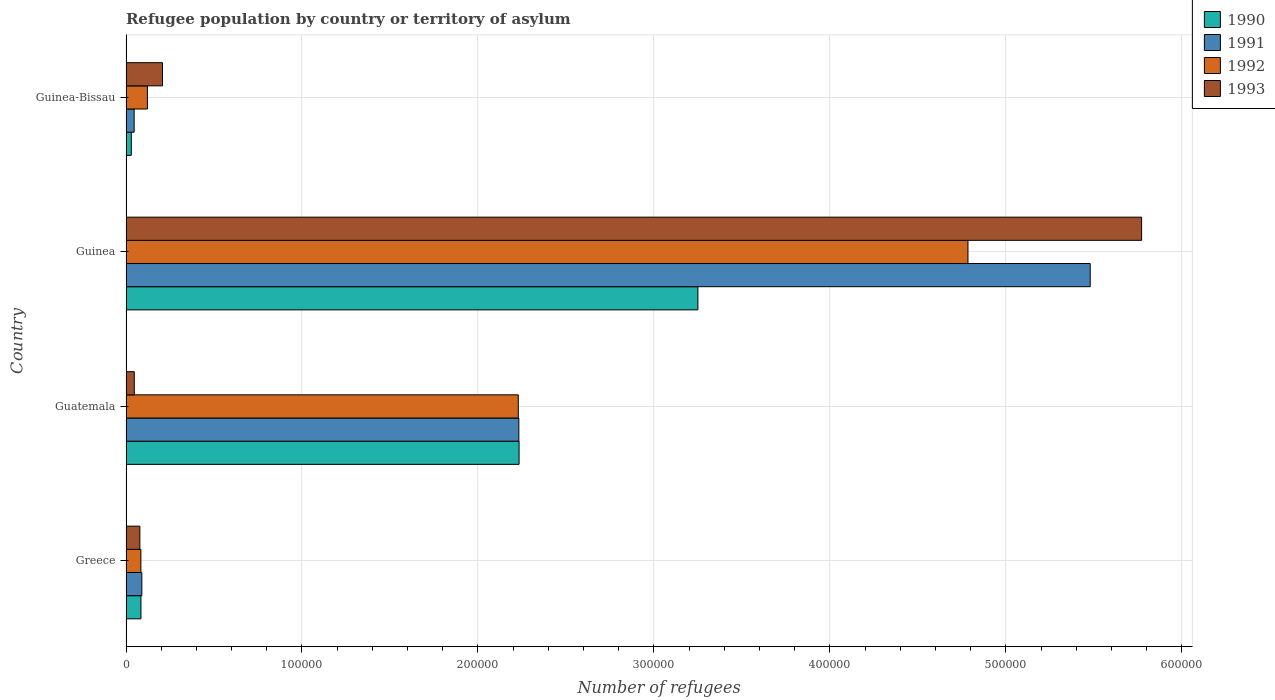How many different coloured bars are there?
Your answer should be compact. 4. How many bars are there on the 3rd tick from the top?
Make the answer very short. 4. How many bars are there on the 2nd tick from the bottom?
Offer a terse response. 4. What is the number of refugees in 1993 in Guinea-Bissau?
Your answer should be compact. 2.07e+04. Across all countries, what is the maximum number of refugees in 1993?
Your answer should be very brief. 5.77e+05. Across all countries, what is the minimum number of refugees in 1992?
Provide a short and direct response. 8456. In which country was the number of refugees in 1992 maximum?
Offer a terse response. Guinea. In which country was the number of refugees in 1990 minimum?
Offer a very short reply. Guinea-Bissau. What is the total number of refugees in 1993 in the graph?
Give a very brief answer. 6.10e+05. What is the difference between the number of refugees in 1993 in Guatemala and that in Guinea-Bissau?
Provide a succinct answer. -1.60e+04. What is the difference between the number of refugees in 1990 in Guinea and the number of refugees in 1993 in Greece?
Give a very brief answer. 3.17e+05. What is the average number of refugees in 1992 per country?
Make the answer very short. 1.81e+05. What is the difference between the number of refugees in 1993 and number of refugees in 1991 in Guinea-Bissau?
Offer a terse response. 1.61e+04. In how many countries, is the number of refugees in 1993 greater than 300000 ?
Offer a very short reply. 1. What is the ratio of the number of refugees in 1993 in Guatemala to that in Guinea-Bissau?
Your response must be concise. 0.23. Is the difference between the number of refugees in 1993 in Greece and Guinea greater than the difference between the number of refugees in 1991 in Greece and Guinea?
Offer a terse response. No. What is the difference between the highest and the second highest number of refugees in 1991?
Give a very brief answer. 3.25e+05. What is the difference between the highest and the lowest number of refugees in 1992?
Make the answer very short. 4.70e+05. Is the sum of the number of refugees in 1990 in Greece and Guinea greater than the maximum number of refugees in 1992 across all countries?
Provide a succinct answer. No. What does the 4th bar from the top in Guinea-Bissau represents?
Make the answer very short. 1990. What does the 2nd bar from the bottom in Greece represents?
Ensure brevity in your answer.  1991. Is it the case that in every country, the sum of the number of refugees in 1991 and number of refugees in 1993 is greater than the number of refugees in 1992?
Ensure brevity in your answer.  Yes. How many bars are there?
Offer a very short reply. 16. Are all the bars in the graph horizontal?
Offer a terse response. Yes. How many countries are there in the graph?
Your response must be concise. 4. What is the difference between two consecutive major ticks on the X-axis?
Your response must be concise. 1.00e+05. Does the graph contain any zero values?
Keep it short and to the point. No. Does the graph contain grids?
Your answer should be very brief. Yes. Where does the legend appear in the graph?
Your response must be concise. Top right. How many legend labels are there?
Make the answer very short. 4. What is the title of the graph?
Provide a short and direct response. Refugee population by country or territory of asylum. Does "1975" appear as one of the legend labels in the graph?
Give a very brief answer. No. What is the label or title of the X-axis?
Offer a terse response. Number of refugees. What is the Number of refugees in 1990 in Greece?
Your answer should be compact. 8488. What is the Number of refugees in 1991 in Greece?
Offer a terse response. 8989. What is the Number of refugees of 1992 in Greece?
Offer a very short reply. 8456. What is the Number of refugees of 1993 in Greece?
Provide a succinct answer. 7873. What is the Number of refugees of 1990 in Guatemala?
Offer a terse response. 2.23e+05. What is the Number of refugees of 1991 in Guatemala?
Make the answer very short. 2.23e+05. What is the Number of refugees of 1992 in Guatemala?
Offer a terse response. 2.23e+05. What is the Number of refugees of 1993 in Guatemala?
Your answer should be very brief. 4689. What is the Number of refugees of 1990 in Guinea?
Your answer should be very brief. 3.25e+05. What is the Number of refugees of 1991 in Guinea?
Keep it short and to the point. 5.48e+05. What is the Number of refugees of 1992 in Guinea?
Keep it short and to the point. 4.78e+05. What is the Number of refugees in 1993 in Guinea?
Give a very brief answer. 5.77e+05. What is the Number of refugees of 1990 in Guinea-Bissau?
Offer a terse response. 3004. What is the Number of refugees of 1991 in Guinea-Bissau?
Ensure brevity in your answer.  4631. What is the Number of refugees in 1992 in Guinea-Bissau?
Keep it short and to the point. 1.22e+04. What is the Number of refugees in 1993 in Guinea-Bissau?
Keep it short and to the point. 2.07e+04. Across all countries, what is the maximum Number of refugees of 1990?
Provide a succinct answer. 3.25e+05. Across all countries, what is the maximum Number of refugees in 1991?
Provide a short and direct response. 5.48e+05. Across all countries, what is the maximum Number of refugees of 1992?
Your answer should be very brief. 4.78e+05. Across all countries, what is the maximum Number of refugees of 1993?
Offer a very short reply. 5.77e+05. Across all countries, what is the minimum Number of refugees in 1990?
Your answer should be very brief. 3004. Across all countries, what is the minimum Number of refugees of 1991?
Offer a very short reply. 4631. Across all countries, what is the minimum Number of refugees in 1992?
Your response must be concise. 8456. Across all countries, what is the minimum Number of refugees of 1993?
Offer a very short reply. 4689. What is the total Number of refugees of 1990 in the graph?
Make the answer very short. 5.60e+05. What is the total Number of refugees of 1991 in the graph?
Your answer should be very brief. 7.85e+05. What is the total Number of refugees of 1992 in the graph?
Provide a succinct answer. 7.22e+05. What is the total Number of refugees in 1993 in the graph?
Give a very brief answer. 6.10e+05. What is the difference between the Number of refugees in 1990 in Greece and that in Guatemala?
Give a very brief answer. -2.15e+05. What is the difference between the Number of refugees of 1991 in Greece and that in Guatemala?
Keep it short and to the point. -2.14e+05. What is the difference between the Number of refugees in 1992 in Greece and that in Guatemala?
Keep it short and to the point. -2.14e+05. What is the difference between the Number of refugees in 1993 in Greece and that in Guatemala?
Make the answer very short. 3184. What is the difference between the Number of refugees in 1990 in Greece and that in Guinea?
Make the answer very short. -3.17e+05. What is the difference between the Number of refugees of 1991 in Greece and that in Guinea?
Offer a very short reply. -5.39e+05. What is the difference between the Number of refugees in 1992 in Greece and that in Guinea?
Ensure brevity in your answer.  -4.70e+05. What is the difference between the Number of refugees of 1993 in Greece and that in Guinea?
Provide a short and direct response. -5.69e+05. What is the difference between the Number of refugees in 1990 in Greece and that in Guinea-Bissau?
Offer a terse response. 5484. What is the difference between the Number of refugees of 1991 in Greece and that in Guinea-Bissau?
Offer a terse response. 4358. What is the difference between the Number of refugees in 1992 in Greece and that in Guinea-Bissau?
Provide a succinct answer. -3707. What is the difference between the Number of refugees of 1993 in Greece and that in Guinea-Bissau?
Ensure brevity in your answer.  -1.29e+04. What is the difference between the Number of refugees in 1990 in Guatemala and that in Guinea?
Offer a very short reply. -1.02e+05. What is the difference between the Number of refugees in 1991 in Guatemala and that in Guinea?
Provide a succinct answer. -3.25e+05. What is the difference between the Number of refugees in 1992 in Guatemala and that in Guinea?
Offer a terse response. -2.56e+05. What is the difference between the Number of refugees of 1993 in Guatemala and that in Guinea?
Your answer should be compact. -5.72e+05. What is the difference between the Number of refugees of 1990 in Guatemala and that in Guinea-Bissau?
Provide a short and direct response. 2.20e+05. What is the difference between the Number of refugees of 1991 in Guatemala and that in Guinea-Bissau?
Make the answer very short. 2.19e+05. What is the difference between the Number of refugees in 1992 in Guatemala and that in Guinea-Bissau?
Give a very brief answer. 2.11e+05. What is the difference between the Number of refugees in 1993 in Guatemala and that in Guinea-Bissau?
Offer a very short reply. -1.60e+04. What is the difference between the Number of refugees of 1990 in Guinea and that in Guinea-Bissau?
Your response must be concise. 3.22e+05. What is the difference between the Number of refugees in 1991 in Guinea and that in Guinea-Bissau?
Offer a terse response. 5.43e+05. What is the difference between the Number of refugees of 1992 in Guinea and that in Guinea-Bissau?
Provide a succinct answer. 4.66e+05. What is the difference between the Number of refugees in 1993 in Guinea and that in Guinea-Bissau?
Your answer should be compact. 5.56e+05. What is the difference between the Number of refugees in 1990 in Greece and the Number of refugees in 1991 in Guatemala?
Your answer should be compact. -2.15e+05. What is the difference between the Number of refugees in 1990 in Greece and the Number of refugees in 1992 in Guatemala?
Make the answer very short. -2.14e+05. What is the difference between the Number of refugees in 1990 in Greece and the Number of refugees in 1993 in Guatemala?
Provide a succinct answer. 3799. What is the difference between the Number of refugees of 1991 in Greece and the Number of refugees of 1992 in Guatemala?
Your answer should be very brief. -2.14e+05. What is the difference between the Number of refugees in 1991 in Greece and the Number of refugees in 1993 in Guatemala?
Keep it short and to the point. 4300. What is the difference between the Number of refugees in 1992 in Greece and the Number of refugees in 1993 in Guatemala?
Make the answer very short. 3767. What is the difference between the Number of refugees in 1990 in Greece and the Number of refugees in 1991 in Guinea?
Provide a succinct answer. -5.39e+05. What is the difference between the Number of refugees of 1990 in Greece and the Number of refugees of 1992 in Guinea?
Keep it short and to the point. -4.70e+05. What is the difference between the Number of refugees in 1990 in Greece and the Number of refugees in 1993 in Guinea?
Give a very brief answer. -5.69e+05. What is the difference between the Number of refugees of 1991 in Greece and the Number of refugees of 1992 in Guinea?
Your response must be concise. -4.70e+05. What is the difference between the Number of refugees of 1991 in Greece and the Number of refugees of 1993 in Guinea?
Keep it short and to the point. -5.68e+05. What is the difference between the Number of refugees of 1992 in Greece and the Number of refugees of 1993 in Guinea?
Give a very brief answer. -5.69e+05. What is the difference between the Number of refugees of 1990 in Greece and the Number of refugees of 1991 in Guinea-Bissau?
Provide a short and direct response. 3857. What is the difference between the Number of refugees of 1990 in Greece and the Number of refugees of 1992 in Guinea-Bissau?
Make the answer very short. -3675. What is the difference between the Number of refugees in 1990 in Greece and the Number of refugees in 1993 in Guinea-Bissau?
Your response must be concise. -1.22e+04. What is the difference between the Number of refugees in 1991 in Greece and the Number of refugees in 1992 in Guinea-Bissau?
Provide a short and direct response. -3174. What is the difference between the Number of refugees of 1991 in Greece and the Number of refugees of 1993 in Guinea-Bissau?
Give a very brief answer. -1.17e+04. What is the difference between the Number of refugees of 1992 in Greece and the Number of refugees of 1993 in Guinea-Bissau?
Your answer should be compact. -1.23e+04. What is the difference between the Number of refugees of 1990 in Guatemala and the Number of refugees of 1991 in Guinea?
Ensure brevity in your answer.  -3.25e+05. What is the difference between the Number of refugees of 1990 in Guatemala and the Number of refugees of 1992 in Guinea?
Offer a very short reply. -2.55e+05. What is the difference between the Number of refugees of 1990 in Guatemala and the Number of refugees of 1993 in Guinea?
Offer a terse response. -3.54e+05. What is the difference between the Number of refugees in 1991 in Guatemala and the Number of refugees in 1992 in Guinea?
Your answer should be very brief. -2.55e+05. What is the difference between the Number of refugees of 1991 in Guatemala and the Number of refugees of 1993 in Guinea?
Offer a terse response. -3.54e+05. What is the difference between the Number of refugees of 1992 in Guatemala and the Number of refugees of 1993 in Guinea?
Your answer should be compact. -3.54e+05. What is the difference between the Number of refugees in 1990 in Guatemala and the Number of refugees in 1991 in Guinea-Bissau?
Your answer should be very brief. 2.19e+05. What is the difference between the Number of refugees of 1990 in Guatemala and the Number of refugees of 1992 in Guinea-Bissau?
Your response must be concise. 2.11e+05. What is the difference between the Number of refugees in 1990 in Guatemala and the Number of refugees in 1993 in Guinea-Bissau?
Your response must be concise. 2.03e+05. What is the difference between the Number of refugees in 1991 in Guatemala and the Number of refugees in 1992 in Guinea-Bissau?
Your answer should be compact. 2.11e+05. What is the difference between the Number of refugees of 1991 in Guatemala and the Number of refugees of 1993 in Guinea-Bissau?
Your answer should be very brief. 2.03e+05. What is the difference between the Number of refugees in 1992 in Guatemala and the Number of refugees in 1993 in Guinea-Bissau?
Keep it short and to the point. 2.02e+05. What is the difference between the Number of refugees of 1990 in Guinea and the Number of refugees of 1991 in Guinea-Bissau?
Your answer should be compact. 3.20e+05. What is the difference between the Number of refugees in 1990 in Guinea and the Number of refugees in 1992 in Guinea-Bissau?
Offer a terse response. 3.13e+05. What is the difference between the Number of refugees of 1990 in Guinea and the Number of refugees of 1993 in Guinea-Bissau?
Your answer should be compact. 3.04e+05. What is the difference between the Number of refugees of 1991 in Guinea and the Number of refugees of 1992 in Guinea-Bissau?
Your response must be concise. 5.36e+05. What is the difference between the Number of refugees in 1991 in Guinea and the Number of refugees in 1993 in Guinea-Bissau?
Your answer should be compact. 5.27e+05. What is the difference between the Number of refugees of 1992 in Guinea and the Number of refugees of 1993 in Guinea-Bissau?
Ensure brevity in your answer.  4.58e+05. What is the average Number of refugees of 1990 per country?
Your answer should be very brief. 1.40e+05. What is the average Number of refugees of 1991 per country?
Keep it short and to the point. 1.96e+05. What is the average Number of refugees of 1992 per country?
Offer a very short reply. 1.81e+05. What is the average Number of refugees of 1993 per country?
Your response must be concise. 1.53e+05. What is the difference between the Number of refugees of 1990 and Number of refugees of 1991 in Greece?
Your answer should be compact. -501. What is the difference between the Number of refugees of 1990 and Number of refugees of 1993 in Greece?
Your answer should be compact. 615. What is the difference between the Number of refugees in 1991 and Number of refugees in 1992 in Greece?
Provide a succinct answer. 533. What is the difference between the Number of refugees in 1991 and Number of refugees in 1993 in Greece?
Your response must be concise. 1116. What is the difference between the Number of refugees in 1992 and Number of refugees in 1993 in Greece?
Provide a short and direct response. 583. What is the difference between the Number of refugees in 1990 and Number of refugees in 1991 in Guatemala?
Ensure brevity in your answer.  141. What is the difference between the Number of refugees of 1990 and Number of refugees of 1992 in Guatemala?
Your answer should be compact. 448. What is the difference between the Number of refugees of 1990 and Number of refugees of 1993 in Guatemala?
Make the answer very short. 2.19e+05. What is the difference between the Number of refugees in 1991 and Number of refugees in 1992 in Guatemala?
Keep it short and to the point. 307. What is the difference between the Number of refugees in 1991 and Number of refugees in 1993 in Guatemala?
Your response must be concise. 2.19e+05. What is the difference between the Number of refugees of 1992 and Number of refugees of 1993 in Guatemala?
Provide a succinct answer. 2.18e+05. What is the difference between the Number of refugees of 1990 and Number of refugees of 1991 in Guinea?
Give a very brief answer. -2.23e+05. What is the difference between the Number of refugees in 1990 and Number of refugees in 1992 in Guinea?
Make the answer very short. -1.53e+05. What is the difference between the Number of refugees of 1990 and Number of refugees of 1993 in Guinea?
Provide a succinct answer. -2.52e+05. What is the difference between the Number of refugees in 1991 and Number of refugees in 1992 in Guinea?
Provide a short and direct response. 6.95e+04. What is the difference between the Number of refugees of 1991 and Number of refugees of 1993 in Guinea?
Your response must be concise. -2.92e+04. What is the difference between the Number of refugees of 1992 and Number of refugees of 1993 in Guinea?
Your answer should be very brief. -9.87e+04. What is the difference between the Number of refugees of 1990 and Number of refugees of 1991 in Guinea-Bissau?
Give a very brief answer. -1627. What is the difference between the Number of refugees of 1990 and Number of refugees of 1992 in Guinea-Bissau?
Your answer should be very brief. -9159. What is the difference between the Number of refugees of 1990 and Number of refugees of 1993 in Guinea-Bissau?
Offer a terse response. -1.77e+04. What is the difference between the Number of refugees in 1991 and Number of refugees in 1992 in Guinea-Bissau?
Offer a terse response. -7532. What is the difference between the Number of refugees of 1991 and Number of refugees of 1993 in Guinea-Bissau?
Make the answer very short. -1.61e+04. What is the difference between the Number of refugees in 1992 and Number of refugees in 1993 in Guinea-Bissau?
Offer a terse response. -8572. What is the ratio of the Number of refugees in 1990 in Greece to that in Guatemala?
Your response must be concise. 0.04. What is the ratio of the Number of refugees in 1991 in Greece to that in Guatemala?
Make the answer very short. 0.04. What is the ratio of the Number of refugees of 1992 in Greece to that in Guatemala?
Keep it short and to the point. 0.04. What is the ratio of the Number of refugees of 1993 in Greece to that in Guatemala?
Make the answer very short. 1.68. What is the ratio of the Number of refugees of 1990 in Greece to that in Guinea?
Your response must be concise. 0.03. What is the ratio of the Number of refugees of 1991 in Greece to that in Guinea?
Your answer should be compact. 0.02. What is the ratio of the Number of refugees in 1992 in Greece to that in Guinea?
Offer a terse response. 0.02. What is the ratio of the Number of refugees of 1993 in Greece to that in Guinea?
Your answer should be very brief. 0.01. What is the ratio of the Number of refugees in 1990 in Greece to that in Guinea-Bissau?
Keep it short and to the point. 2.83. What is the ratio of the Number of refugees of 1991 in Greece to that in Guinea-Bissau?
Make the answer very short. 1.94. What is the ratio of the Number of refugees in 1992 in Greece to that in Guinea-Bissau?
Your answer should be compact. 0.7. What is the ratio of the Number of refugees in 1993 in Greece to that in Guinea-Bissau?
Give a very brief answer. 0.38. What is the ratio of the Number of refugees in 1990 in Guatemala to that in Guinea?
Your answer should be very brief. 0.69. What is the ratio of the Number of refugees of 1991 in Guatemala to that in Guinea?
Your answer should be compact. 0.41. What is the ratio of the Number of refugees of 1992 in Guatemala to that in Guinea?
Provide a succinct answer. 0.47. What is the ratio of the Number of refugees of 1993 in Guatemala to that in Guinea?
Offer a very short reply. 0.01. What is the ratio of the Number of refugees of 1990 in Guatemala to that in Guinea-Bissau?
Offer a terse response. 74.36. What is the ratio of the Number of refugees of 1991 in Guatemala to that in Guinea-Bissau?
Give a very brief answer. 48.2. What is the ratio of the Number of refugees in 1992 in Guatemala to that in Guinea-Bissau?
Ensure brevity in your answer.  18.33. What is the ratio of the Number of refugees in 1993 in Guatemala to that in Guinea-Bissau?
Offer a very short reply. 0.23. What is the ratio of the Number of refugees of 1990 in Guinea to that in Guinea-Bissau?
Offer a terse response. 108.19. What is the ratio of the Number of refugees in 1991 in Guinea to that in Guinea-Bissau?
Provide a succinct answer. 118.32. What is the ratio of the Number of refugees of 1992 in Guinea to that in Guinea-Bissau?
Offer a terse response. 39.34. What is the ratio of the Number of refugees of 1993 in Guinea to that in Guinea-Bissau?
Make the answer very short. 27.84. What is the difference between the highest and the second highest Number of refugees of 1990?
Provide a short and direct response. 1.02e+05. What is the difference between the highest and the second highest Number of refugees in 1991?
Give a very brief answer. 3.25e+05. What is the difference between the highest and the second highest Number of refugees of 1992?
Make the answer very short. 2.56e+05. What is the difference between the highest and the second highest Number of refugees of 1993?
Provide a short and direct response. 5.56e+05. What is the difference between the highest and the lowest Number of refugees in 1990?
Give a very brief answer. 3.22e+05. What is the difference between the highest and the lowest Number of refugees of 1991?
Provide a succinct answer. 5.43e+05. What is the difference between the highest and the lowest Number of refugees of 1992?
Your answer should be very brief. 4.70e+05. What is the difference between the highest and the lowest Number of refugees of 1993?
Give a very brief answer. 5.72e+05. 